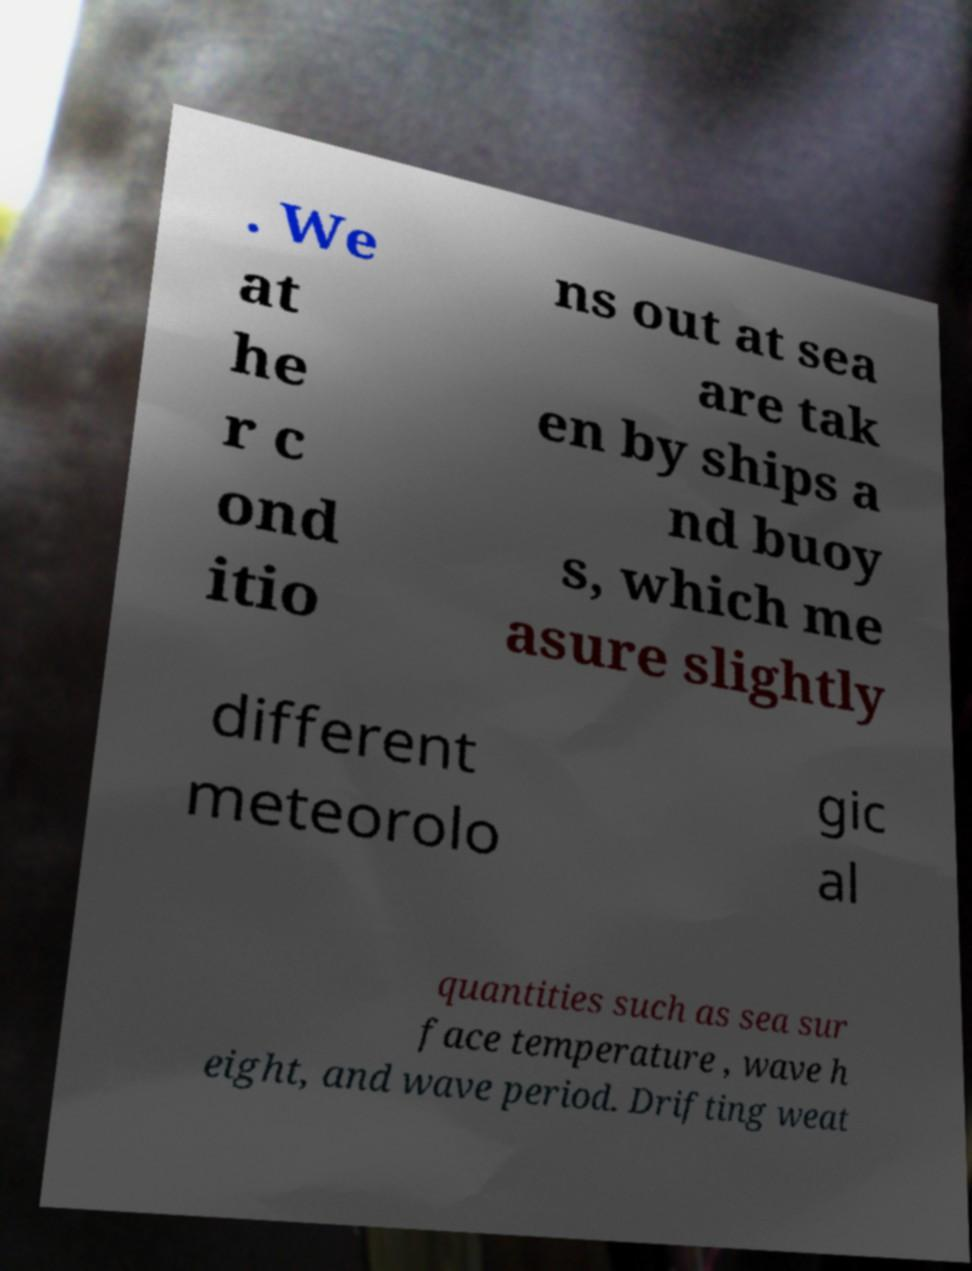Can you read and provide the text displayed in the image?This photo seems to have some interesting text. Can you extract and type it out for me? . We at he r c ond itio ns out at sea are tak en by ships a nd buoy s, which me asure slightly different meteorolo gic al quantities such as sea sur face temperature , wave h eight, and wave period. Drifting weat 